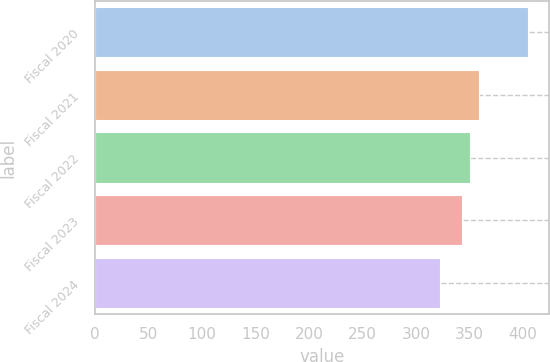<chart> <loc_0><loc_0><loc_500><loc_500><bar_chart><fcel>Fiscal 2020<fcel>Fiscal 2021<fcel>Fiscal 2022<fcel>Fiscal 2023<fcel>Fiscal 2024<nl><fcel>404.2<fcel>359.08<fcel>350.89<fcel>342.7<fcel>322.3<nl></chart> 